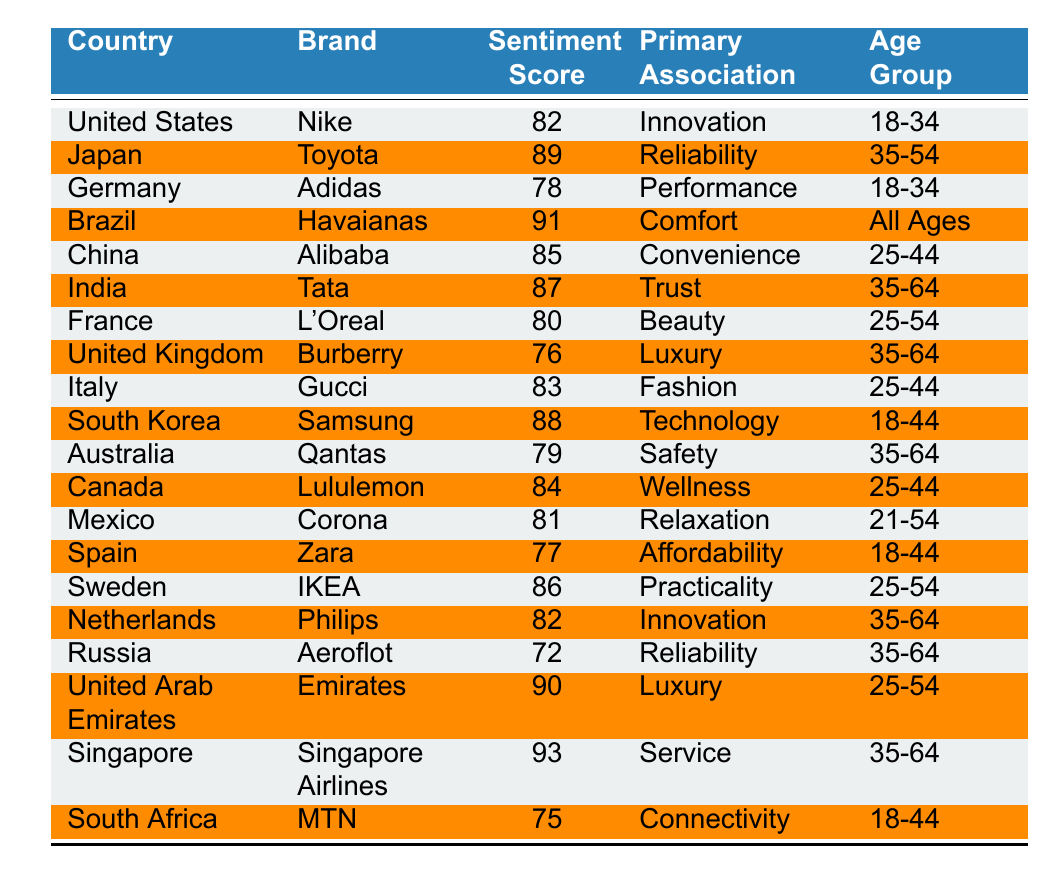What is the sentiment score for Nike in the United States? The table shows the sentiment score for Nike in the United States as 82.
Answer: 82 Which brand has the highest sentiment score? Looking through the table, Singapore Airlines has the highest sentiment score of 93.
Answer: Singapore Airlines What is the primary association of Havaianas in Brazil? The table indicates that the primary association of Havaianas in Brazil is Comfort.
Answer: Comfort Which country has a brand associated with Beauty? The table lists L'Oreal in France as the brand associated with Beauty.
Answer: France What is the sentiment score difference between Adidas in Germany and Zara in Spain? Adidas has a sentiment score of 78 and Zara has 77; the difference is 78 - 77 = 1.
Answer: 1 Is the primary association of Emirates in the United Arab Emirates Luxury? The table confirms that Emirates is indeed associated with Luxury.
Answer: Yes What is the average sentiment score for brands associated with the age group 35-64? The scores for that age group are: Tata (87), Burberry (76), Aeroflot (72), Emirates (90), and Singapore Airlines (93). Summing these gives 418, and dividing by 5 gives an average of 83.6.
Answer: 83.6 Which brand in the table has the lowest sentiment score, and what is it? Aeroflot in Russia has the lowest sentiment score of 72.
Answer: Aeroflot, 72 How many brands have a sentiment score above 85? The brands with scores above 85 are Toyota (89), Havaianas (91), Tata (87), Samsung (88), IKEA (86), Emirates (90), and Singapore Airlines (93). That's a total of 7 brands.
Answer: 7 What is the primary association of the brand with the highest sentiment score? Singapore Airlines has the highest sentiment score of 93 and is associated with Service.
Answer: Service 